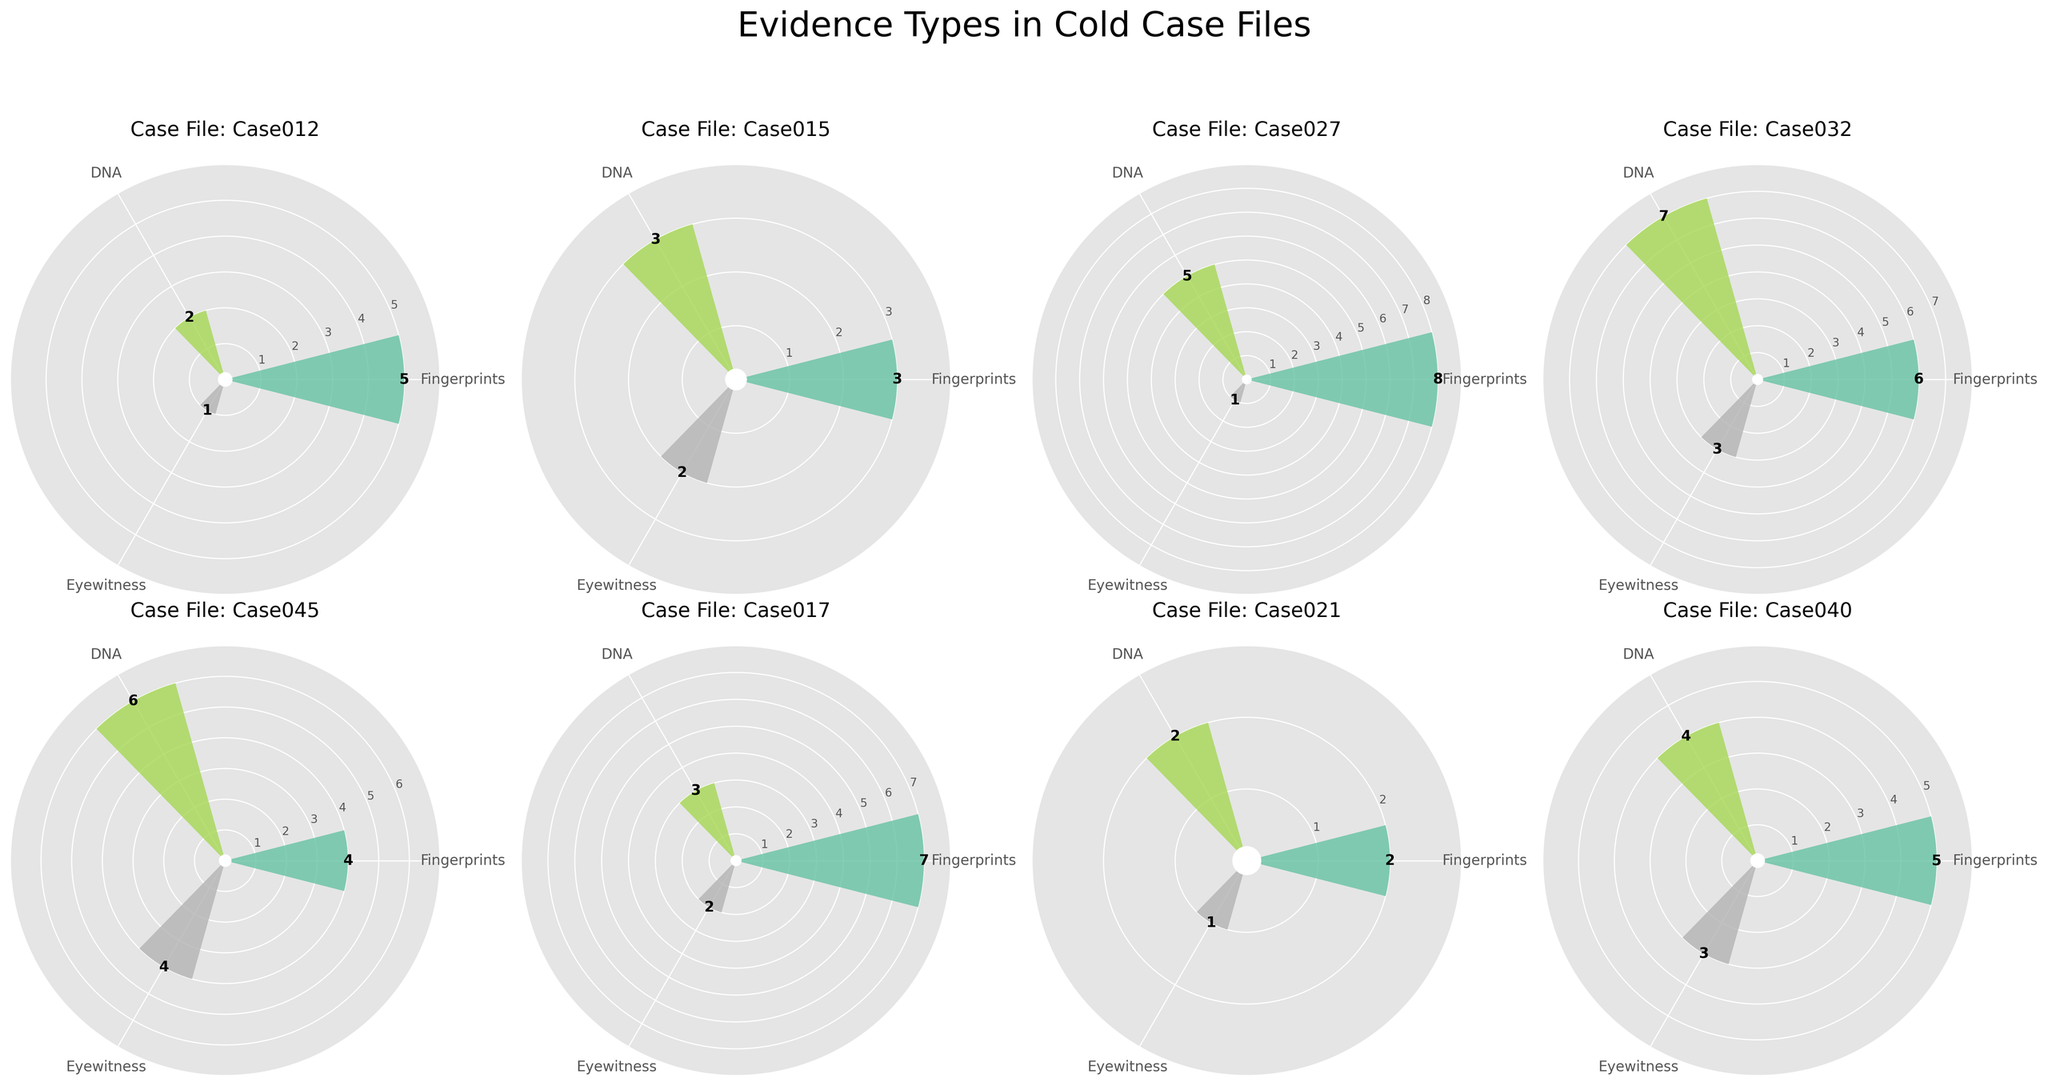What is the title of the figure? The title of a figure helps us understand the overall topic or purpose of the visualization. At the top of the figure, the title is "Evidence Types in Cold Case Files".
Answer: Evidence Types in Cold Case Files What are the evidence types displayed in each rose chart? By looking at the labels around one of the rose charts, we can see different evidence types such as Fingerprints, DNA, and Eyewitness.
Answer: Fingerprints, DNA, Eyewitness Which case file has the highest quantity of "DNA" evidence? To determine this, we need to examine the segments labeled 'DNA' in each rose chart and see which one has the highest value. "Case032" displays a value of 7 for DNA, which is the highest among all cases.
Answer: Case032 How many case files are included in the figure? The subplots show individual rose charts for each case file. Counting the number of unique rose charts will give us the number of case files. There are 8 case files in total.
Answer: 8 What is the combined quantity of "Fingerprints" evidence across all case files? To find the combined quantity of Fingerprints, we sum up the Fingerprints values from each rose chart: 5+3+8+6+4+7+2+5 = 40
Answer: 40 Which case file has the lowest quantity of "Eyewitness" evidence? By comparing the Eyewitness evidence segments in each rose chart, we see that "Case012" has the lowest value of 1.
Answer: Case012 What is the average quantity of "DNA" evidence across all case files? To calculate the average, sum the quantities of DNA evidence from all case files and divide by the number of cases: (2+3+5+7+6+3+2+4) / 8 = 32 / 8 = 4
Answer: 4 Which case file has an equal quantity of "Fingerprints" and "Eyewitness" evidence? Looking at each rose chart, we see that "Case017" has equal quantities for Fingerprints and Eyewitness, both being 7 and 2, respectively.
Answer: Case017 Compare the total quantities of "Fingerprints" and "DNA" evidence in "Case045". Which is higher? By how much? In "Case045", the quantity for Fingerprints is 4, and for DNA, it is 6. The quantity of DNA evidence is higher by 2 (6 - 4 = 2).
Answer: DNA by 2 